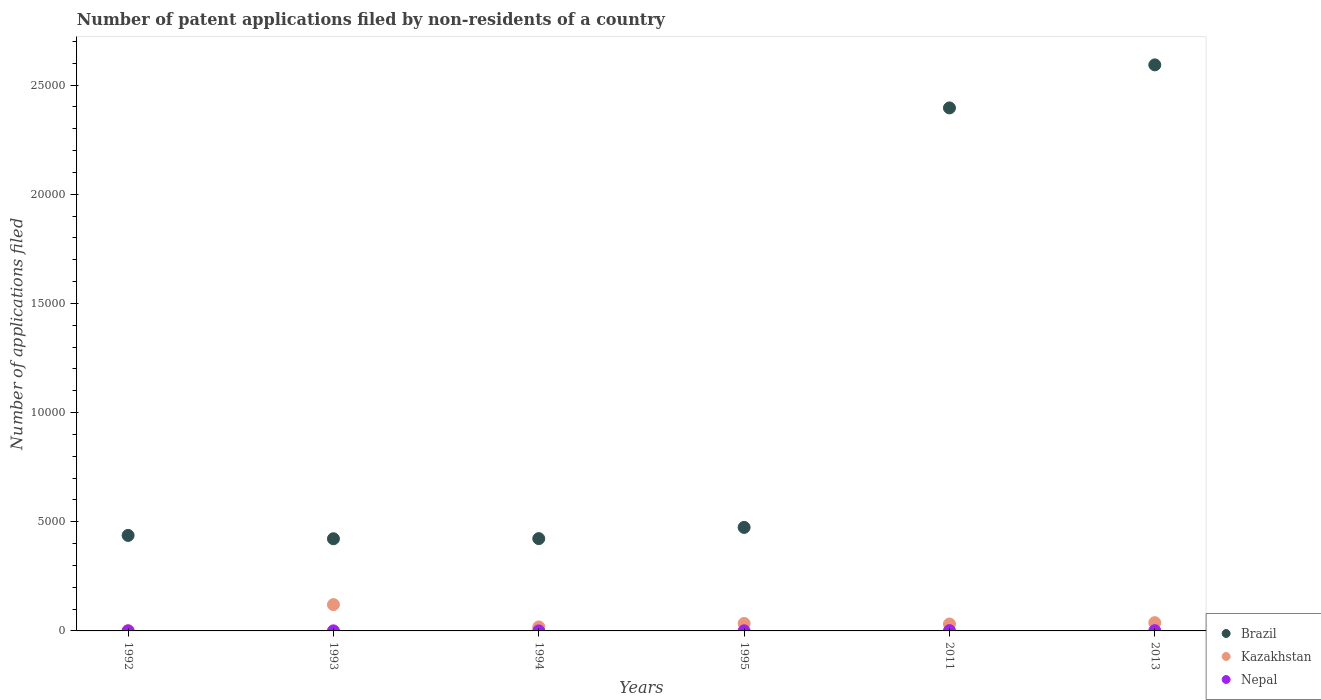How many different coloured dotlines are there?
Provide a succinct answer. 3. Across all years, what is the maximum number of applications filed in Brazil?
Give a very brief answer. 2.59e+04. In which year was the number of applications filed in Brazil minimum?
Give a very brief answer. 1993. What is the total number of applications filed in Brazil in the graph?
Offer a terse response. 6.74e+04. What is the difference between the number of applications filed in Kazakhstan in 1993 and that in 1994?
Give a very brief answer. 1022. What is the difference between the number of applications filed in Kazakhstan in 1993 and the number of applications filed in Brazil in 1992?
Keep it short and to the point. -3169. What is the average number of applications filed in Kazakhstan per year?
Ensure brevity in your answer.  406.17. In the year 2013, what is the difference between the number of applications filed in Kazakhstan and number of applications filed in Brazil?
Provide a short and direct response. -2.55e+04. What is the ratio of the number of applications filed in Kazakhstan in 1992 to that in 1993?
Provide a short and direct response. 0.01. Is the difference between the number of applications filed in Kazakhstan in 1994 and 2013 greater than the difference between the number of applications filed in Brazil in 1994 and 2013?
Offer a very short reply. Yes. What is the difference between the highest and the second highest number of applications filed in Brazil?
Provide a short and direct response. 1971. Is it the case that in every year, the sum of the number of applications filed in Nepal and number of applications filed in Kazakhstan  is greater than the number of applications filed in Brazil?
Give a very brief answer. No. Does the number of applications filed in Brazil monotonically increase over the years?
Your answer should be compact. No. What is the difference between two consecutive major ticks on the Y-axis?
Offer a terse response. 5000. Where does the legend appear in the graph?
Give a very brief answer. Bottom right. What is the title of the graph?
Provide a short and direct response. Number of patent applications filed by non-residents of a country. Does "Least developed countries" appear as one of the legend labels in the graph?
Ensure brevity in your answer.  No. What is the label or title of the X-axis?
Make the answer very short. Years. What is the label or title of the Y-axis?
Offer a terse response. Number of applications filed. What is the Number of applications filed of Brazil in 1992?
Offer a terse response. 4374. What is the Number of applications filed of Kazakhstan in 1992?
Your answer should be compact. 12. What is the Number of applications filed of Brazil in 1993?
Your response must be concise. 4221. What is the Number of applications filed in Kazakhstan in 1993?
Offer a very short reply. 1205. What is the Number of applications filed of Nepal in 1993?
Give a very brief answer. 3. What is the Number of applications filed in Brazil in 1994?
Keep it short and to the point. 4228. What is the Number of applications filed in Kazakhstan in 1994?
Your answer should be very brief. 183. What is the Number of applications filed of Nepal in 1994?
Your answer should be very brief. 1. What is the Number of applications filed in Brazil in 1995?
Your response must be concise. 4741. What is the Number of applications filed of Kazakhstan in 1995?
Your response must be concise. 342. What is the Number of applications filed of Brazil in 2011?
Offer a very short reply. 2.40e+04. What is the Number of applications filed in Kazakhstan in 2011?
Offer a terse response. 317. What is the Number of applications filed in Brazil in 2013?
Your answer should be compact. 2.59e+04. What is the Number of applications filed in Kazakhstan in 2013?
Your response must be concise. 378. Across all years, what is the maximum Number of applications filed in Brazil?
Your answer should be very brief. 2.59e+04. Across all years, what is the maximum Number of applications filed of Kazakhstan?
Your response must be concise. 1205. Across all years, what is the minimum Number of applications filed of Brazil?
Provide a short and direct response. 4221. Across all years, what is the minimum Number of applications filed in Kazakhstan?
Your answer should be very brief. 12. Across all years, what is the minimum Number of applications filed of Nepal?
Make the answer very short. 1. What is the total Number of applications filed of Brazil in the graph?
Offer a very short reply. 6.74e+04. What is the total Number of applications filed of Kazakhstan in the graph?
Your answer should be very brief. 2437. What is the total Number of applications filed in Nepal in the graph?
Provide a succinct answer. 38. What is the difference between the Number of applications filed of Brazil in 1992 and that in 1993?
Keep it short and to the point. 153. What is the difference between the Number of applications filed in Kazakhstan in 1992 and that in 1993?
Offer a terse response. -1193. What is the difference between the Number of applications filed in Brazil in 1992 and that in 1994?
Ensure brevity in your answer.  146. What is the difference between the Number of applications filed of Kazakhstan in 1992 and that in 1994?
Make the answer very short. -171. What is the difference between the Number of applications filed in Nepal in 1992 and that in 1994?
Your answer should be compact. 1. What is the difference between the Number of applications filed in Brazil in 1992 and that in 1995?
Your answer should be compact. -367. What is the difference between the Number of applications filed in Kazakhstan in 1992 and that in 1995?
Provide a short and direct response. -330. What is the difference between the Number of applications filed in Brazil in 1992 and that in 2011?
Your answer should be compact. -1.96e+04. What is the difference between the Number of applications filed of Kazakhstan in 1992 and that in 2011?
Provide a succinct answer. -305. What is the difference between the Number of applications filed in Nepal in 1992 and that in 2011?
Offer a very short reply. -13. What is the difference between the Number of applications filed of Brazil in 1992 and that in 2013?
Your response must be concise. -2.16e+04. What is the difference between the Number of applications filed of Kazakhstan in 1992 and that in 2013?
Keep it short and to the point. -366. What is the difference between the Number of applications filed of Nepal in 1992 and that in 2013?
Your answer should be very brief. -10. What is the difference between the Number of applications filed of Brazil in 1993 and that in 1994?
Provide a succinct answer. -7. What is the difference between the Number of applications filed of Kazakhstan in 1993 and that in 1994?
Make the answer very short. 1022. What is the difference between the Number of applications filed of Brazil in 1993 and that in 1995?
Offer a terse response. -520. What is the difference between the Number of applications filed of Kazakhstan in 1993 and that in 1995?
Keep it short and to the point. 863. What is the difference between the Number of applications filed in Nepal in 1993 and that in 1995?
Keep it short and to the point. -2. What is the difference between the Number of applications filed of Brazil in 1993 and that in 2011?
Offer a terse response. -1.97e+04. What is the difference between the Number of applications filed in Kazakhstan in 1993 and that in 2011?
Make the answer very short. 888. What is the difference between the Number of applications filed of Nepal in 1993 and that in 2011?
Ensure brevity in your answer.  -12. What is the difference between the Number of applications filed in Brazil in 1993 and that in 2013?
Provide a short and direct response. -2.17e+04. What is the difference between the Number of applications filed in Kazakhstan in 1993 and that in 2013?
Keep it short and to the point. 827. What is the difference between the Number of applications filed in Brazil in 1994 and that in 1995?
Offer a very short reply. -513. What is the difference between the Number of applications filed in Kazakhstan in 1994 and that in 1995?
Make the answer very short. -159. What is the difference between the Number of applications filed in Nepal in 1994 and that in 1995?
Your answer should be compact. -4. What is the difference between the Number of applications filed in Brazil in 1994 and that in 2011?
Offer a very short reply. -1.97e+04. What is the difference between the Number of applications filed of Kazakhstan in 1994 and that in 2011?
Offer a very short reply. -134. What is the difference between the Number of applications filed in Nepal in 1994 and that in 2011?
Offer a very short reply. -14. What is the difference between the Number of applications filed in Brazil in 1994 and that in 2013?
Offer a very short reply. -2.17e+04. What is the difference between the Number of applications filed of Kazakhstan in 1994 and that in 2013?
Provide a succinct answer. -195. What is the difference between the Number of applications filed of Brazil in 1995 and that in 2011?
Provide a succinct answer. -1.92e+04. What is the difference between the Number of applications filed of Brazil in 1995 and that in 2013?
Give a very brief answer. -2.12e+04. What is the difference between the Number of applications filed in Kazakhstan in 1995 and that in 2013?
Offer a very short reply. -36. What is the difference between the Number of applications filed in Brazil in 2011 and that in 2013?
Your response must be concise. -1971. What is the difference between the Number of applications filed of Kazakhstan in 2011 and that in 2013?
Give a very brief answer. -61. What is the difference between the Number of applications filed in Brazil in 1992 and the Number of applications filed in Kazakhstan in 1993?
Provide a short and direct response. 3169. What is the difference between the Number of applications filed in Brazil in 1992 and the Number of applications filed in Nepal in 1993?
Your response must be concise. 4371. What is the difference between the Number of applications filed in Brazil in 1992 and the Number of applications filed in Kazakhstan in 1994?
Give a very brief answer. 4191. What is the difference between the Number of applications filed of Brazil in 1992 and the Number of applications filed of Nepal in 1994?
Your response must be concise. 4373. What is the difference between the Number of applications filed of Kazakhstan in 1992 and the Number of applications filed of Nepal in 1994?
Your answer should be very brief. 11. What is the difference between the Number of applications filed in Brazil in 1992 and the Number of applications filed in Kazakhstan in 1995?
Your answer should be compact. 4032. What is the difference between the Number of applications filed of Brazil in 1992 and the Number of applications filed of Nepal in 1995?
Give a very brief answer. 4369. What is the difference between the Number of applications filed of Brazil in 1992 and the Number of applications filed of Kazakhstan in 2011?
Offer a terse response. 4057. What is the difference between the Number of applications filed of Brazil in 1992 and the Number of applications filed of Nepal in 2011?
Offer a terse response. 4359. What is the difference between the Number of applications filed in Brazil in 1992 and the Number of applications filed in Kazakhstan in 2013?
Offer a very short reply. 3996. What is the difference between the Number of applications filed in Brazil in 1992 and the Number of applications filed in Nepal in 2013?
Make the answer very short. 4362. What is the difference between the Number of applications filed of Brazil in 1993 and the Number of applications filed of Kazakhstan in 1994?
Provide a short and direct response. 4038. What is the difference between the Number of applications filed in Brazil in 1993 and the Number of applications filed in Nepal in 1994?
Your answer should be very brief. 4220. What is the difference between the Number of applications filed of Kazakhstan in 1993 and the Number of applications filed of Nepal in 1994?
Offer a terse response. 1204. What is the difference between the Number of applications filed of Brazil in 1993 and the Number of applications filed of Kazakhstan in 1995?
Ensure brevity in your answer.  3879. What is the difference between the Number of applications filed of Brazil in 1993 and the Number of applications filed of Nepal in 1995?
Offer a very short reply. 4216. What is the difference between the Number of applications filed of Kazakhstan in 1993 and the Number of applications filed of Nepal in 1995?
Keep it short and to the point. 1200. What is the difference between the Number of applications filed in Brazil in 1993 and the Number of applications filed in Kazakhstan in 2011?
Your answer should be compact. 3904. What is the difference between the Number of applications filed in Brazil in 1993 and the Number of applications filed in Nepal in 2011?
Your answer should be compact. 4206. What is the difference between the Number of applications filed in Kazakhstan in 1993 and the Number of applications filed in Nepal in 2011?
Provide a short and direct response. 1190. What is the difference between the Number of applications filed in Brazil in 1993 and the Number of applications filed in Kazakhstan in 2013?
Make the answer very short. 3843. What is the difference between the Number of applications filed of Brazil in 1993 and the Number of applications filed of Nepal in 2013?
Your answer should be very brief. 4209. What is the difference between the Number of applications filed of Kazakhstan in 1993 and the Number of applications filed of Nepal in 2013?
Your answer should be very brief. 1193. What is the difference between the Number of applications filed of Brazil in 1994 and the Number of applications filed of Kazakhstan in 1995?
Your answer should be very brief. 3886. What is the difference between the Number of applications filed in Brazil in 1994 and the Number of applications filed in Nepal in 1995?
Ensure brevity in your answer.  4223. What is the difference between the Number of applications filed in Kazakhstan in 1994 and the Number of applications filed in Nepal in 1995?
Provide a short and direct response. 178. What is the difference between the Number of applications filed of Brazil in 1994 and the Number of applications filed of Kazakhstan in 2011?
Your response must be concise. 3911. What is the difference between the Number of applications filed of Brazil in 1994 and the Number of applications filed of Nepal in 2011?
Your answer should be compact. 4213. What is the difference between the Number of applications filed of Kazakhstan in 1994 and the Number of applications filed of Nepal in 2011?
Provide a short and direct response. 168. What is the difference between the Number of applications filed of Brazil in 1994 and the Number of applications filed of Kazakhstan in 2013?
Make the answer very short. 3850. What is the difference between the Number of applications filed of Brazil in 1994 and the Number of applications filed of Nepal in 2013?
Your answer should be very brief. 4216. What is the difference between the Number of applications filed in Kazakhstan in 1994 and the Number of applications filed in Nepal in 2013?
Provide a succinct answer. 171. What is the difference between the Number of applications filed of Brazil in 1995 and the Number of applications filed of Kazakhstan in 2011?
Provide a short and direct response. 4424. What is the difference between the Number of applications filed of Brazil in 1995 and the Number of applications filed of Nepal in 2011?
Your answer should be compact. 4726. What is the difference between the Number of applications filed of Kazakhstan in 1995 and the Number of applications filed of Nepal in 2011?
Your response must be concise. 327. What is the difference between the Number of applications filed of Brazil in 1995 and the Number of applications filed of Kazakhstan in 2013?
Make the answer very short. 4363. What is the difference between the Number of applications filed of Brazil in 1995 and the Number of applications filed of Nepal in 2013?
Offer a terse response. 4729. What is the difference between the Number of applications filed in Kazakhstan in 1995 and the Number of applications filed in Nepal in 2013?
Make the answer very short. 330. What is the difference between the Number of applications filed in Brazil in 2011 and the Number of applications filed in Kazakhstan in 2013?
Your answer should be very brief. 2.36e+04. What is the difference between the Number of applications filed in Brazil in 2011 and the Number of applications filed in Nepal in 2013?
Your answer should be very brief. 2.39e+04. What is the difference between the Number of applications filed in Kazakhstan in 2011 and the Number of applications filed in Nepal in 2013?
Offer a very short reply. 305. What is the average Number of applications filed in Brazil per year?
Keep it short and to the point. 1.12e+04. What is the average Number of applications filed of Kazakhstan per year?
Offer a terse response. 406.17. What is the average Number of applications filed of Nepal per year?
Give a very brief answer. 6.33. In the year 1992, what is the difference between the Number of applications filed in Brazil and Number of applications filed in Kazakhstan?
Provide a succinct answer. 4362. In the year 1992, what is the difference between the Number of applications filed of Brazil and Number of applications filed of Nepal?
Provide a short and direct response. 4372. In the year 1992, what is the difference between the Number of applications filed in Kazakhstan and Number of applications filed in Nepal?
Your response must be concise. 10. In the year 1993, what is the difference between the Number of applications filed of Brazil and Number of applications filed of Kazakhstan?
Provide a short and direct response. 3016. In the year 1993, what is the difference between the Number of applications filed of Brazil and Number of applications filed of Nepal?
Your answer should be compact. 4218. In the year 1993, what is the difference between the Number of applications filed of Kazakhstan and Number of applications filed of Nepal?
Provide a succinct answer. 1202. In the year 1994, what is the difference between the Number of applications filed in Brazil and Number of applications filed in Kazakhstan?
Your answer should be very brief. 4045. In the year 1994, what is the difference between the Number of applications filed of Brazil and Number of applications filed of Nepal?
Keep it short and to the point. 4227. In the year 1994, what is the difference between the Number of applications filed of Kazakhstan and Number of applications filed of Nepal?
Provide a succinct answer. 182. In the year 1995, what is the difference between the Number of applications filed in Brazil and Number of applications filed in Kazakhstan?
Ensure brevity in your answer.  4399. In the year 1995, what is the difference between the Number of applications filed of Brazil and Number of applications filed of Nepal?
Give a very brief answer. 4736. In the year 1995, what is the difference between the Number of applications filed of Kazakhstan and Number of applications filed of Nepal?
Ensure brevity in your answer.  337. In the year 2011, what is the difference between the Number of applications filed in Brazil and Number of applications filed in Kazakhstan?
Ensure brevity in your answer.  2.36e+04. In the year 2011, what is the difference between the Number of applications filed of Brazil and Number of applications filed of Nepal?
Ensure brevity in your answer.  2.39e+04. In the year 2011, what is the difference between the Number of applications filed of Kazakhstan and Number of applications filed of Nepal?
Ensure brevity in your answer.  302. In the year 2013, what is the difference between the Number of applications filed of Brazil and Number of applications filed of Kazakhstan?
Your response must be concise. 2.55e+04. In the year 2013, what is the difference between the Number of applications filed in Brazil and Number of applications filed in Nepal?
Provide a short and direct response. 2.59e+04. In the year 2013, what is the difference between the Number of applications filed in Kazakhstan and Number of applications filed in Nepal?
Keep it short and to the point. 366. What is the ratio of the Number of applications filed of Brazil in 1992 to that in 1993?
Provide a short and direct response. 1.04. What is the ratio of the Number of applications filed of Brazil in 1992 to that in 1994?
Offer a terse response. 1.03. What is the ratio of the Number of applications filed of Kazakhstan in 1992 to that in 1994?
Give a very brief answer. 0.07. What is the ratio of the Number of applications filed of Nepal in 1992 to that in 1994?
Your answer should be very brief. 2. What is the ratio of the Number of applications filed in Brazil in 1992 to that in 1995?
Make the answer very short. 0.92. What is the ratio of the Number of applications filed of Kazakhstan in 1992 to that in 1995?
Your answer should be very brief. 0.04. What is the ratio of the Number of applications filed in Brazil in 1992 to that in 2011?
Your answer should be compact. 0.18. What is the ratio of the Number of applications filed of Kazakhstan in 1992 to that in 2011?
Offer a very short reply. 0.04. What is the ratio of the Number of applications filed in Nepal in 1992 to that in 2011?
Provide a short and direct response. 0.13. What is the ratio of the Number of applications filed in Brazil in 1992 to that in 2013?
Keep it short and to the point. 0.17. What is the ratio of the Number of applications filed in Kazakhstan in 1992 to that in 2013?
Make the answer very short. 0.03. What is the ratio of the Number of applications filed in Kazakhstan in 1993 to that in 1994?
Offer a terse response. 6.58. What is the ratio of the Number of applications filed in Brazil in 1993 to that in 1995?
Ensure brevity in your answer.  0.89. What is the ratio of the Number of applications filed of Kazakhstan in 1993 to that in 1995?
Your answer should be compact. 3.52. What is the ratio of the Number of applications filed of Brazil in 1993 to that in 2011?
Offer a terse response. 0.18. What is the ratio of the Number of applications filed in Kazakhstan in 1993 to that in 2011?
Your answer should be compact. 3.8. What is the ratio of the Number of applications filed in Nepal in 1993 to that in 2011?
Your answer should be compact. 0.2. What is the ratio of the Number of applications filed in Brazil in 1993 to that in 2013?
Offer a terse response. 0.16. What is the ratio of the Number of applications filed in Kazakhstan in 1993 to that in 2013?
Give a very brief answer. 3.19. What is the ratio of the Number of applications filed of Brazil in 1994 to that in 1995?
Ensure brevity in your answer.  0.89. What is the ratio of the Number of applications filed of Kazakhstan in 1994 to that in 1995?
Provide a succinct answer. 0.54. What is the ratio of the Number of applications filed of Brazil in 1994 to that in 2011?
Offer a terse response. 0.18. What is the ratio of the Number of applications filed in Kazakhstan in 1994 to that in 2011?
Your answer should be very brief. 0.58. What is the ratio of the Number of applications filed of Nepal in 1994 to that in 2011?
Provide a succinct answer. 0.07. What is the ratio of the Number of applications filed in Brazil in 1994 to that in 2013?
Your answer should be compact. 0.16. What is the ratio of the Number of applications filed of Kazakhstan in 1994 to that in 2013?
Provide a succinct answer. 0.48. What is the ratio of the Number of applications filed of Nepal in 1994 to that in 2013?
Your answer should be very brief. 0.08. What is the ratio of the Number of applications filed in Brazil in 1995 to that in 2011?
Keep it short and to the point. 0.2. What is the ratio of the Number of applications filed in Kazakhstan in 1995 to that in 2011?
Offer a terse response. 1.08. What is the ratio of the Number of applications filed of Nepal in 1995 to that in 2011?
Offer a terse response. 0.33. What is the ratio of the Number of applications filed in Brazil in 1995 to that in 2013?
Provide a succinct answer. 0.18. What is the ratio of the Number of applications filed in Kazakhstan in 1995 to that in 2013?
Your answer should be very brief. 0.9. What is the ratio of the Number of applications filed of Nepal in 1995 to that in 2013?
Ensure brevity in your answer.  0.42. What is the ratio of the Number of applications filed of Brazil in 2011 to that in 2013?
Your answer should be very brief. 0.92. What is the ratio of the Number of applications filed of Kazakhstan in 2011 to that in 2013?
Your response must be concise. 0.84. What is the difference between the highest and the second highest Number of applications filed of Brazil?
Give a very brief answer. 1971. What is the difference between the highest and the second highest Number of applications filed of Kazakhstan?
Provide a short and direct response. 827. What is the difference between the highest and the lowest Number of applications filed in Brazil?
Keep it short and to the point. 2.17e+04. What is the difference between the highest and the lowest Number of applications filed of Kazakhstan?
Offer a terse response. 1193. What is the difference between the highest and the lowest Number of applications filed in Nepal?
Your answer should be compact. 14. 